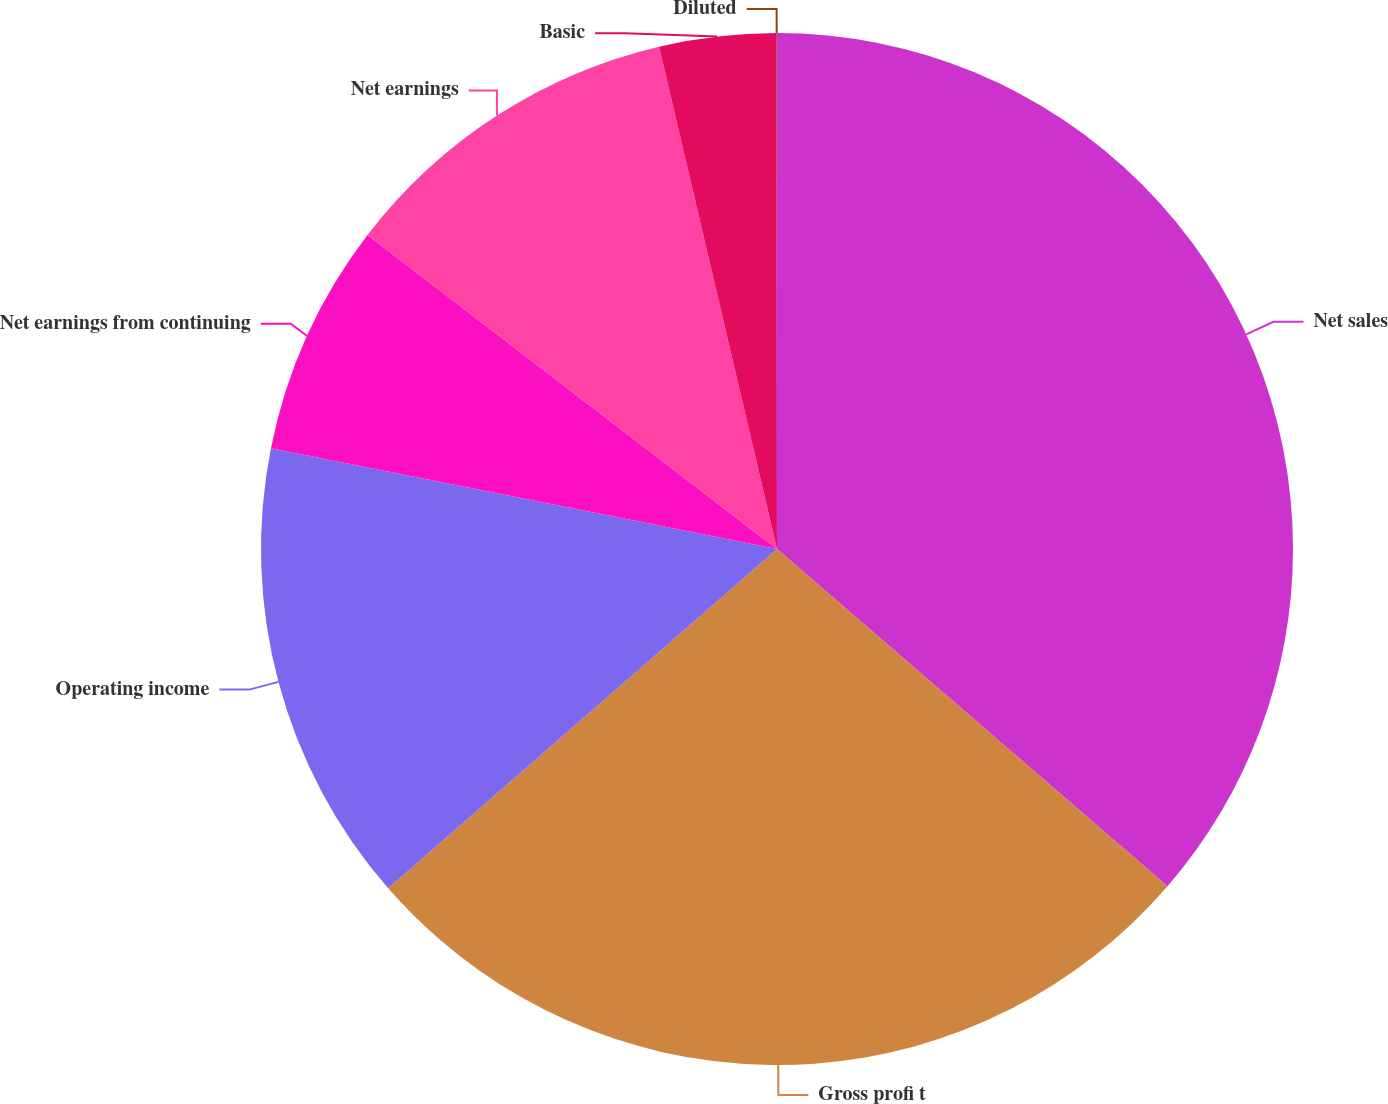<chart> <loc_0><loc_0><loc_500><loc_500><pie_chart><fcel>Net sales<fcel>Gross profi t<fcel>Operating income<fcel>Net earnings from continuing<fcel>Net earnings<fcel>Basic<fcel>Diluted<nl><fcel>36.34%<fcel>27.24%<fcel>14.55%<fcel>7.28%<fcel>10.92%<fcel>3.65%<fcel>0.02%<nl></chart> 